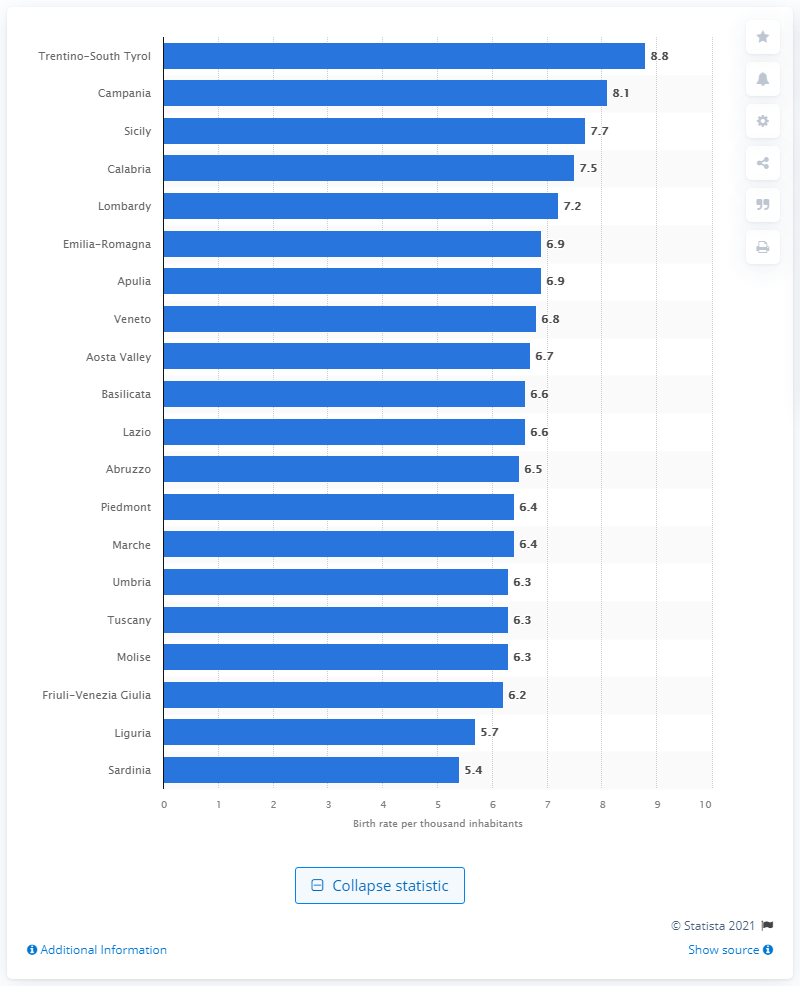Give some essential details in this illustration. In 2019, the birth rate in Trentino-South Tyrol was 8.8 per 1,000 inhabitants. 